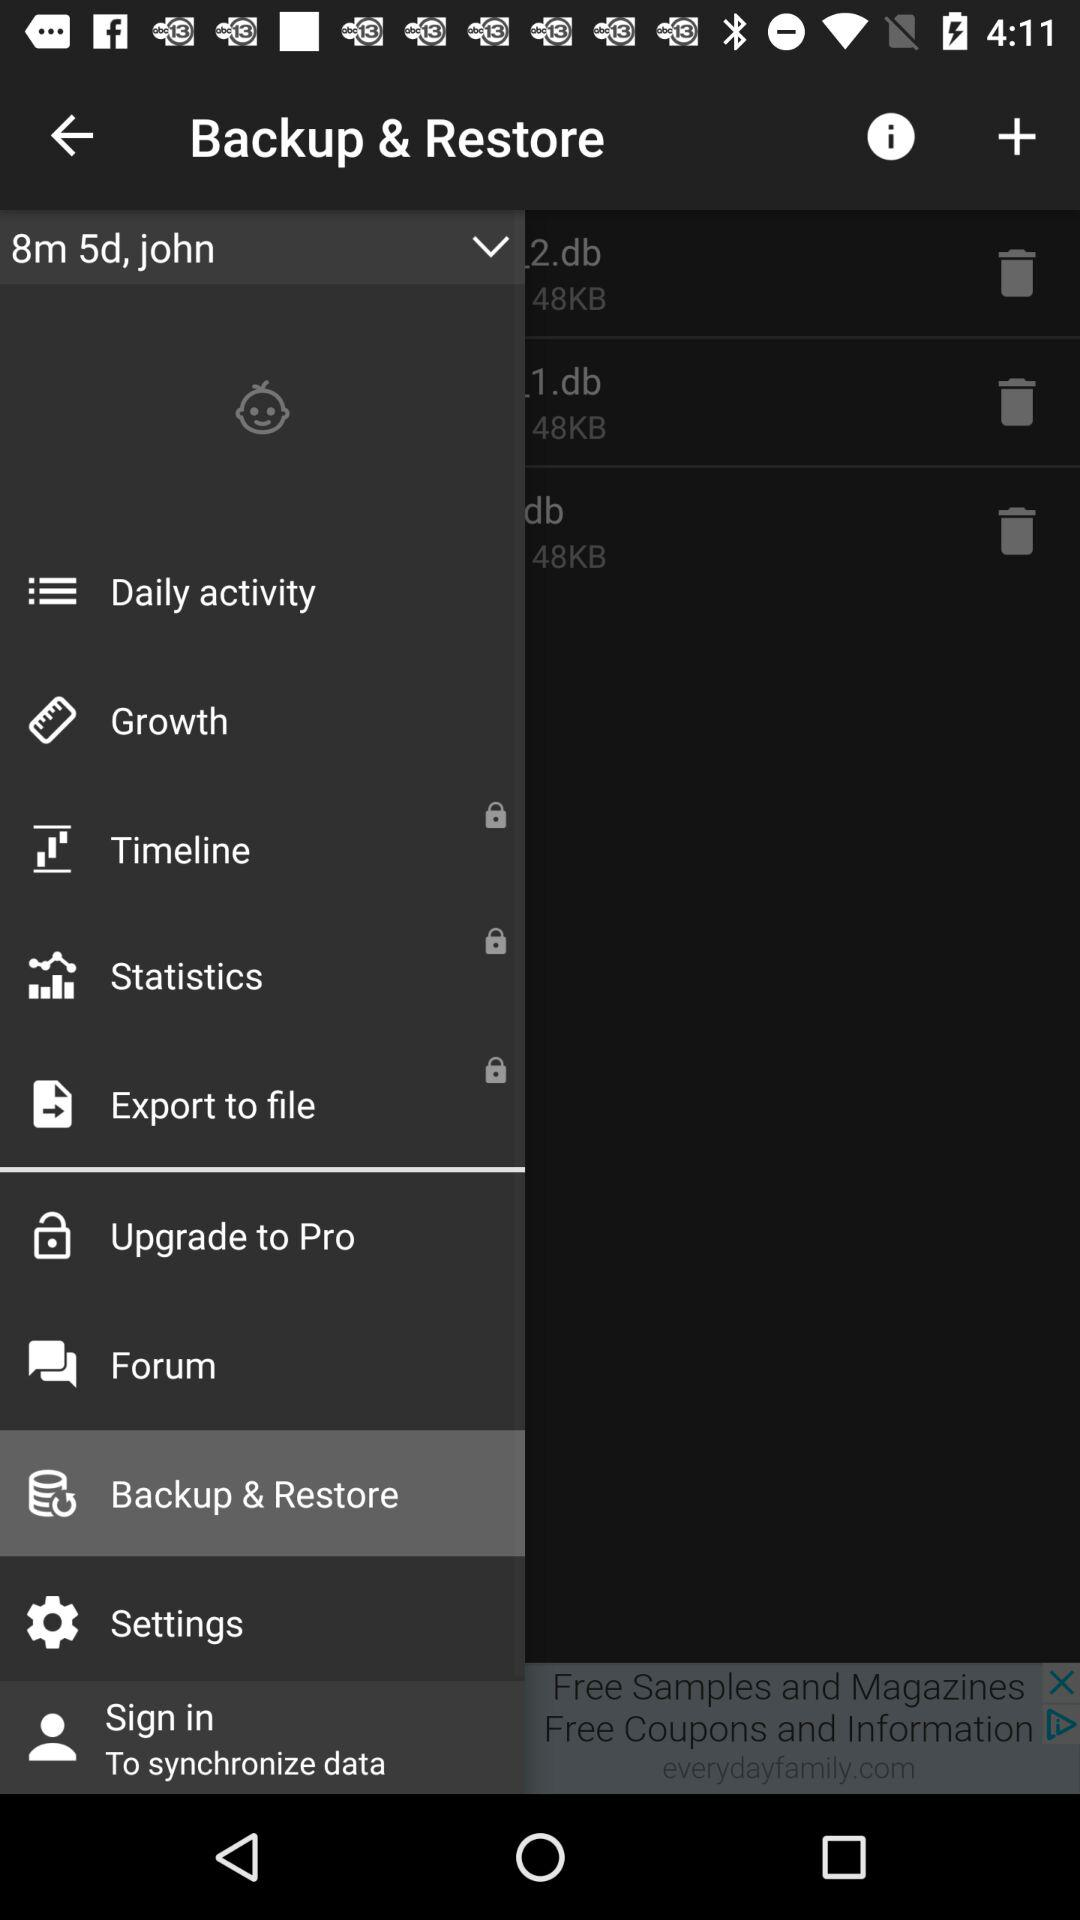What is the name of the user? The name of the user is John. 